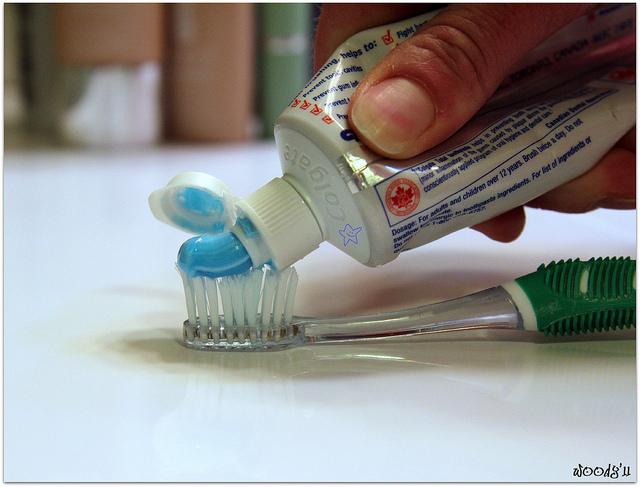What is being but on the toothbrush?
Quick response, please. Toothpaste. What brand of toothpaste is this?
Concise answer only. Colgate. What blue symbol is on the top of the toothpaste tube?
Quick response, please. Star. 